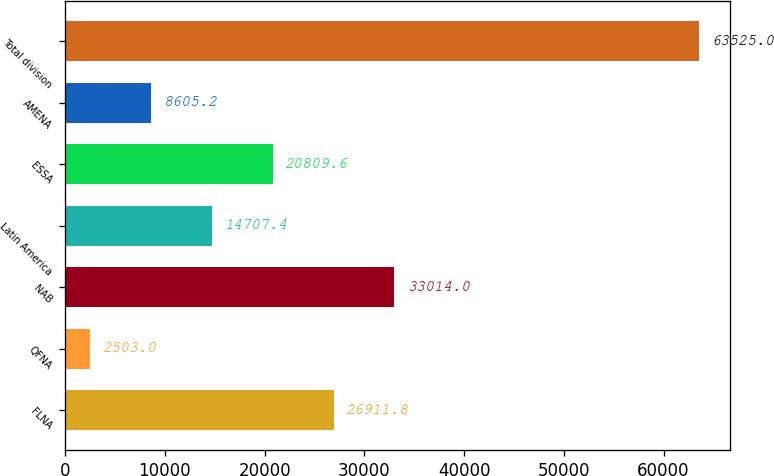Convert chart. <chart><loc_0><loc_0><loc_500><loc_500><bar_chart><fcel>FLNA<fcel>QFNA<fcel>NAB<fcel>Latin America<fcel>ESSA<fcel>AMENA<fcel>Total division<nl><fcel>26911.8<fcel>2503<fcel>33014<fcel>14707.4<fcel>20809.6<fcel>8605.2<fcel>63525<nl></chart> 